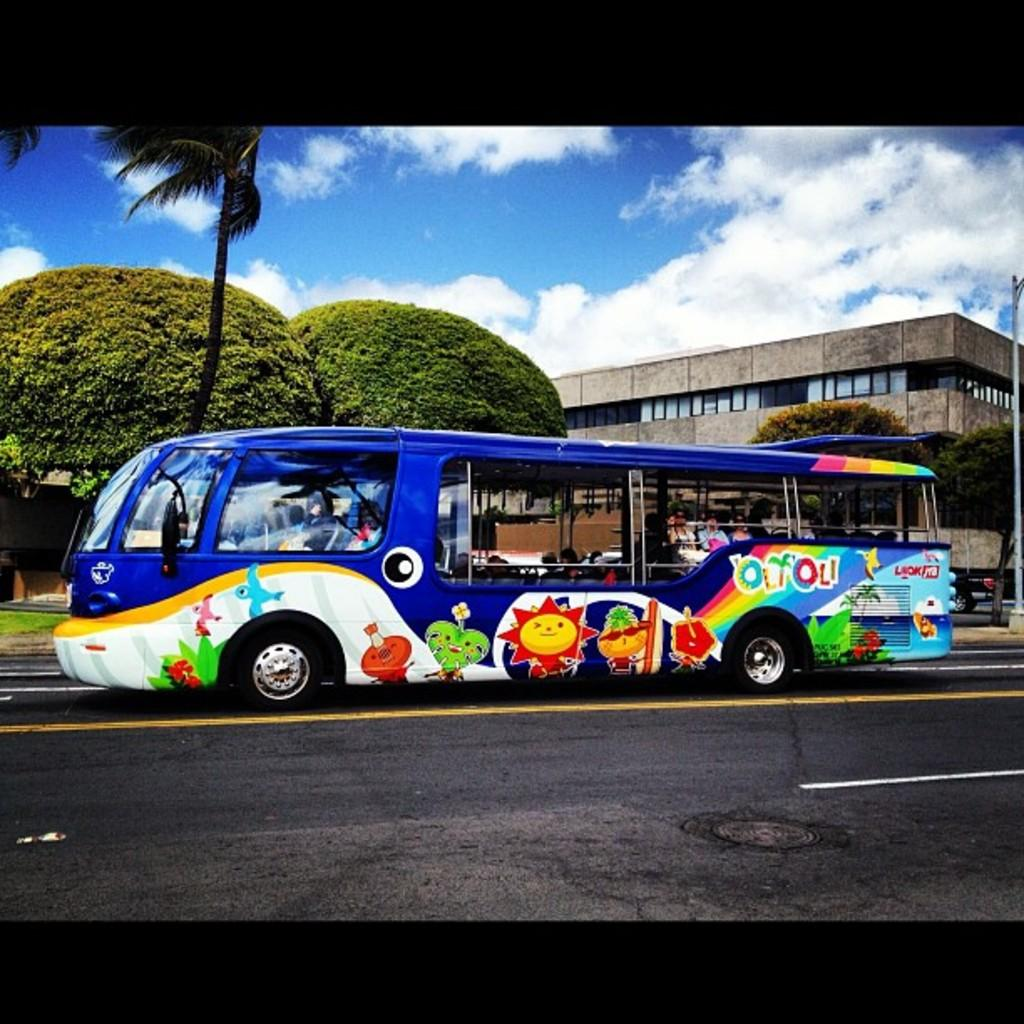<image>
Share a concise interpretation of the image provided. A colorful bus that says Olyoli on it features different animals and symbols. 